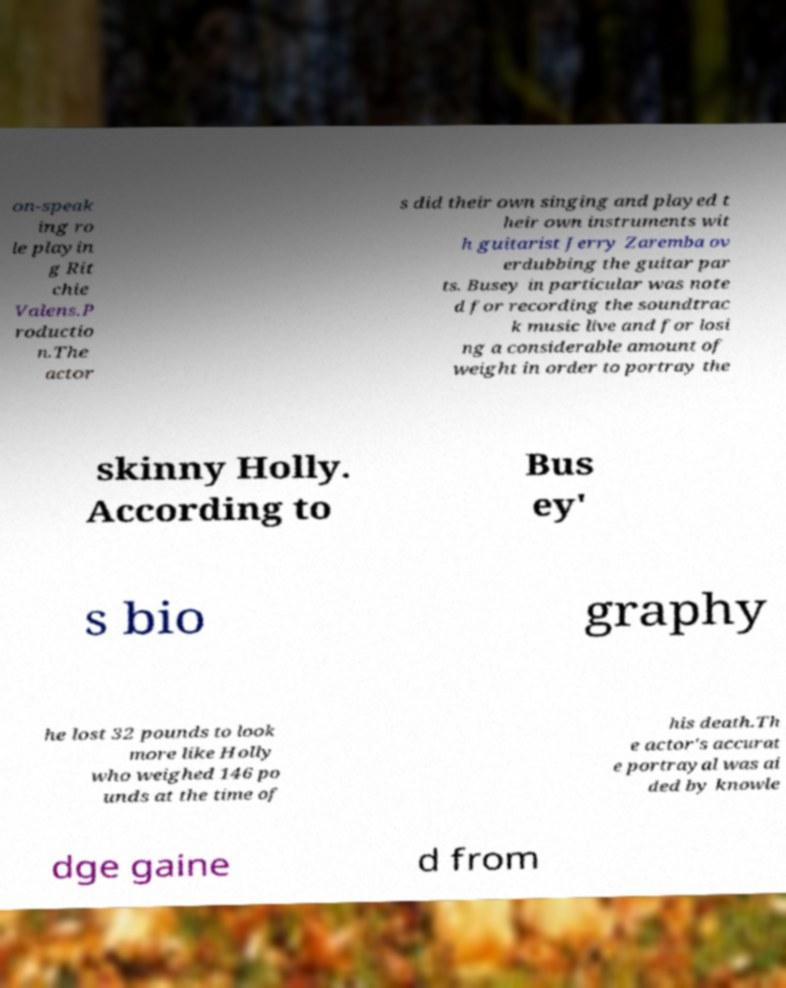For documentation purposes, I need the text within this image transcribed. Could you provide that? on-speak ing ro le playin g Rit chie Valens.P roductio n.The actor s did their own singing and played t heir own instruments wit h guitarist Jerry Zaremba ov erdubbing the guitar par ts. Busey in particular was note d for recording the soundtrac k music live and for losi ng a considerable amount of weight in order to portray the skinny Holly. According to Bus ey' s bio graphy he lost 32 pounds to look more like Holly who weighed 146 po unds at the time of his death.Th e actor's accurat e portrayal was ai ded by knowle dge gaine d from 